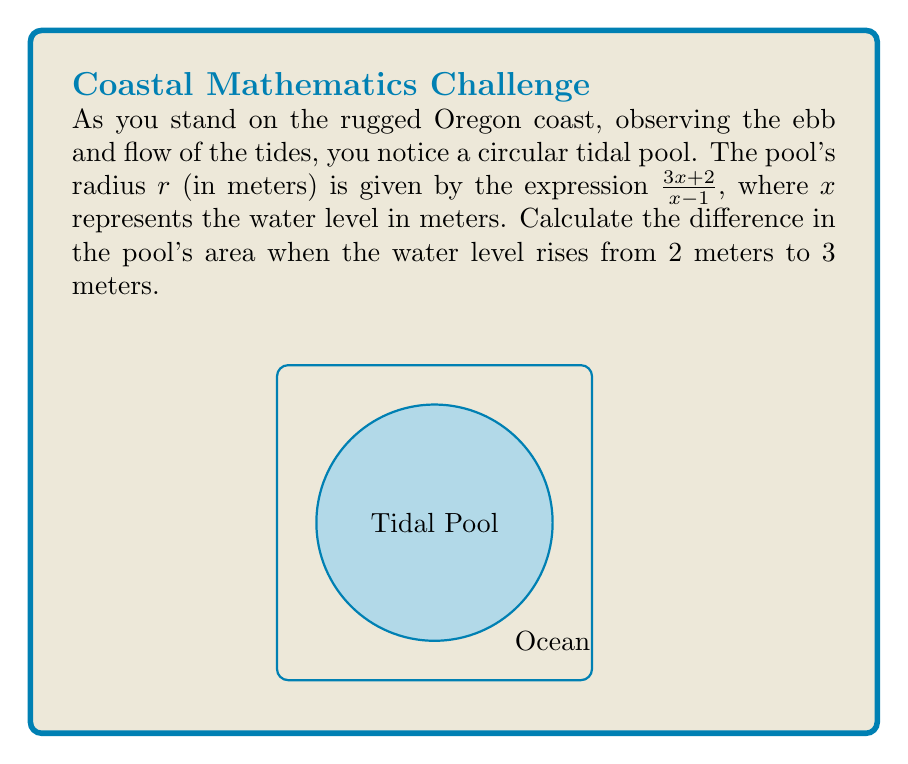Solve this math problem. Let's approach this step-by-step:

1) The area of a circle is given by $A = \pi r^2$. We need to calculate this for two different water levels and find the difference.

2) For $x = 2$ (2 meters water level):
   $r = \frac{3(2)+2}{2-1} = \frac{8}{1} = 8$ meters
   $A_1 = \pi (8)^2 = 64\pi$ square meters

3) For $x = 3$ (3 meters water level):
   $r = \frac{3(3)+2}{3-1} = \frac{11}{2} = 5.5$ meters
   $A_2 = \pi (5.5)^2 = 30.25\pi$ square meters

4) The difference in area:
   $\Delta A = A_1 - A_2 = 64\pi - 30.25\pi = 33.75\pi$ square meters

Note: We kept $\pi$ in its symbolic form for precision.
Answer: $33.75\pi$ square meters 